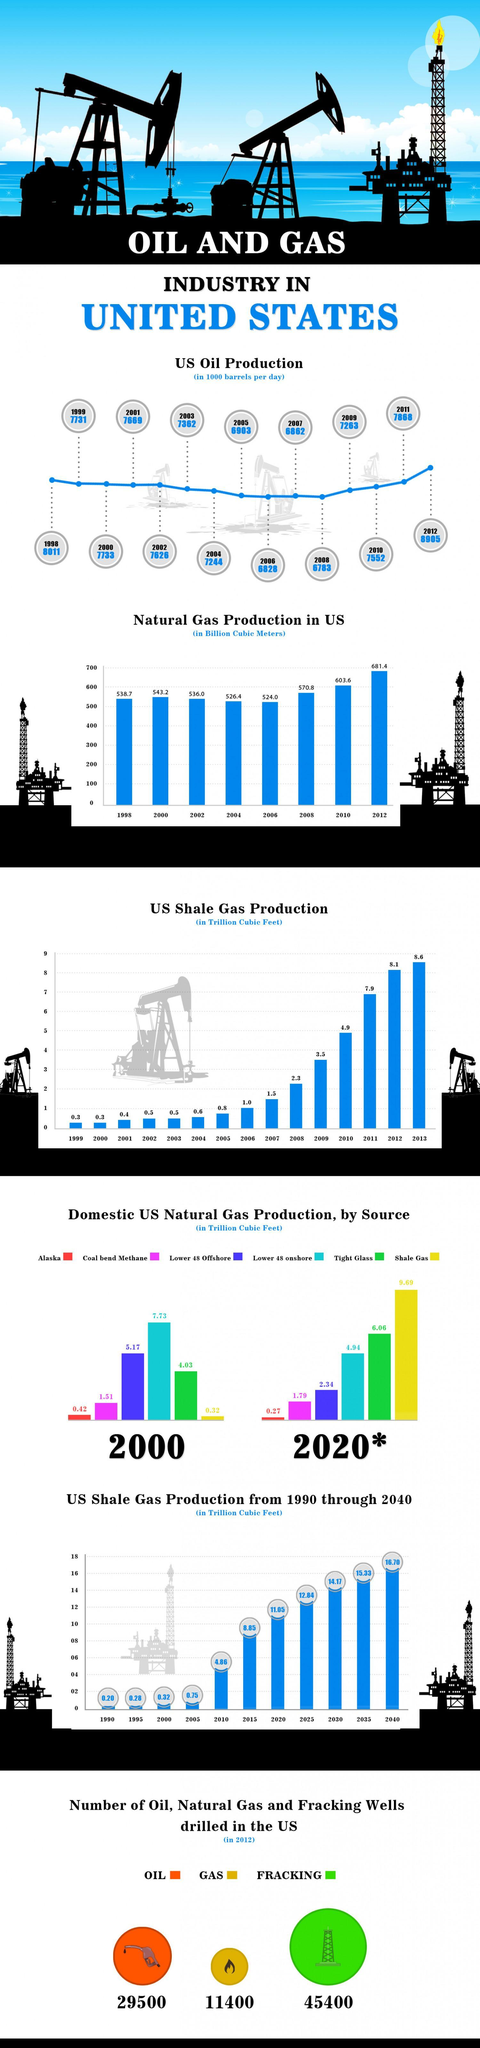In which year the US Shale  Gas Production is estimated to be highest since 1999?
Answer the question with a short phrase. 2013 What is the number of natural gas wells drilled in US in the year 2012? 11400 What is the Natural Gas Production in US (in Billion Cubic  Meters) in the year 2006? 524.0 What is the domestic US Natural gas production(in Trillion Cubic Feet) by Alaska in 2020? 0.27 What is the domestic US Natural gas production(in Trillion Cubic Feet) by Alaska in 2000? 0.42 In which year the US Shale  Gas Production is estimated to be  second highest since 1999? 2012 What is the US oil production (in 1000 barrels per day) in the year 2005? 6903 Which year has the second lowest value in the Natural gas production in US? 2004 What is the number of oil wells drilled in the US in 2012? 29500 What is the number of fracking wells drilled in the US in 2012? 45400 